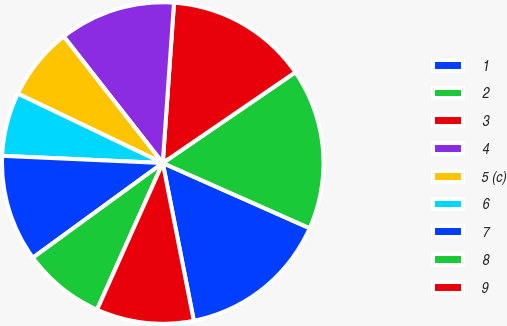Convert chart. <chart><loc_0><loc_0><loc_500><loc_500><pie_chart><fcel>1<fcel>2<fcel>3<fcel>4<fcel>5 (c)<fcel>6<fcel>7<fcel>8<fcel>9<nl><fcel>15.26%<fcel>16.2%<fcel>14.33%<fcel>11.68%<fcel>7.33%<fcel>6.39%<fcel>10.74%<fcel>8.27%<fcel>9.8%<nl></chart> 